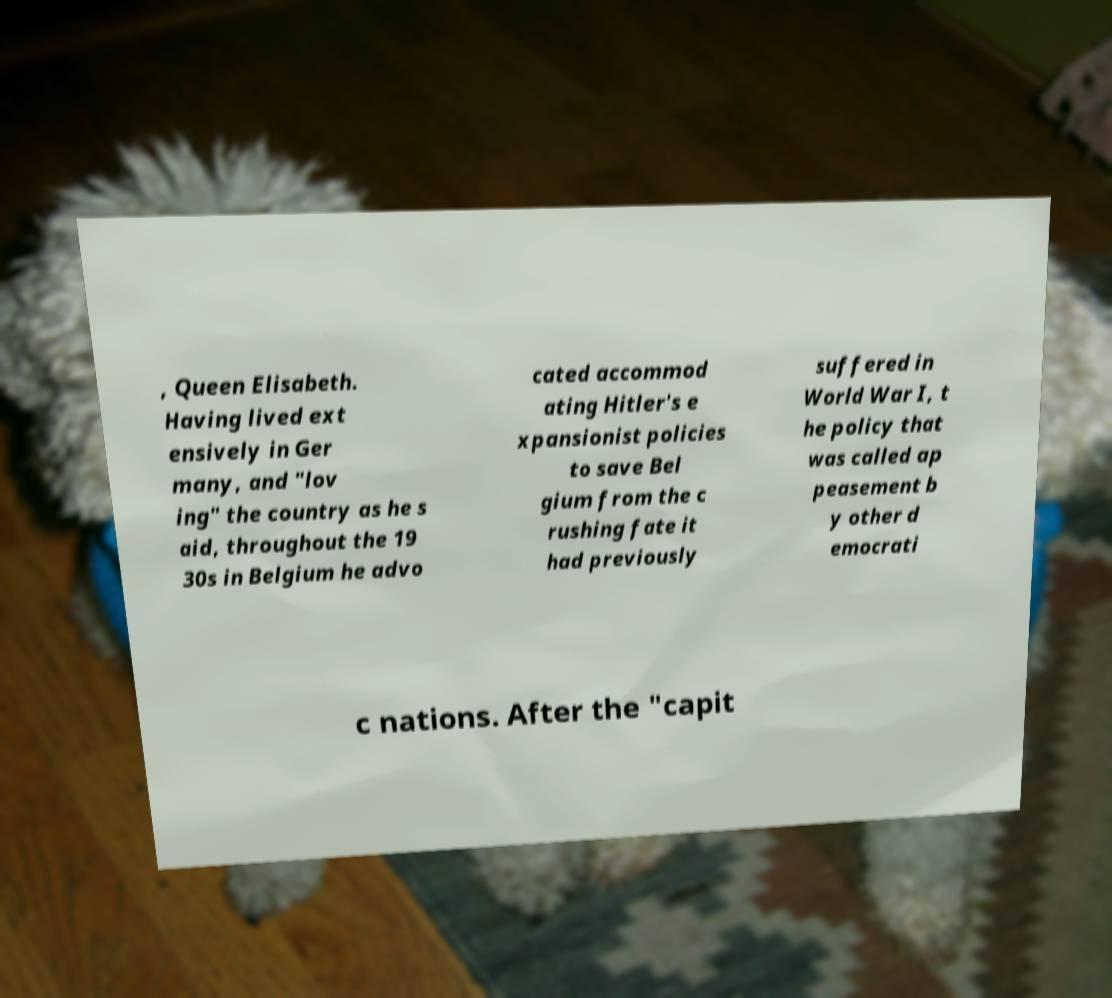There's text embedded in this image that I need extracted. Can you transcribe it verbatim? , Queen Elisabeth. Having lived ext ensively in Ger many, and "lov ing" the country as he s aid, throughout the 19 30s in Belgium he advo cated accommod ating Hitler's e xpansionist policies to save Bel gium from the c rushing fate it had previously suffered in World War I, t he policy that was called ap peasement b y other d emocrati c nations. After the "capit 